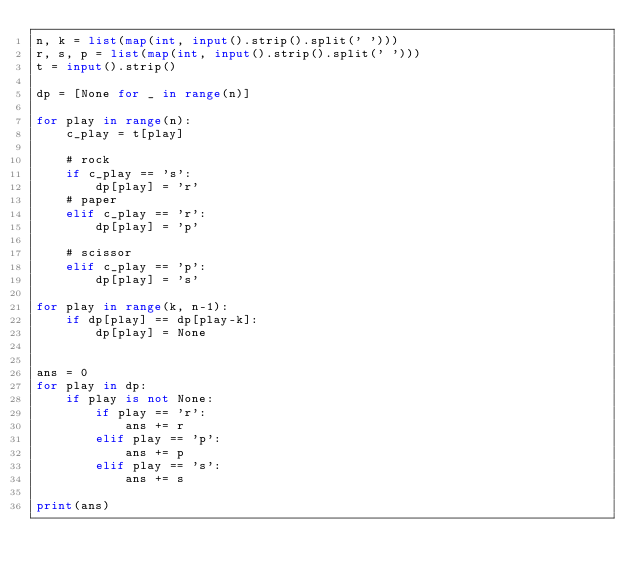<code> <loc_0><loc_0><loc_500><loc_500><_Python_>n, k = list(map(int, input().strip().split(' ')))
r, s, p = list(map(int, input().strip().split(' ')))
t = input().strip()

dp = [None for _ in range(n)]

for play in range(n):
    c_play = t[play] 

    # rock
    if c_play == 's':
        dp[play] = 'r'
    # paper
    elif c_play == 'r':
        dp[play] = 'p'

    # scissor
    elif c_play == 'p':
        dp[play] = 's'

for play in range(k, n-1):
    if dp[play] == dp[play-k]:
        dp[play] = None


ans = 0
for play in dp:
    if play is not None:
        if play == 'r':
            ans += r
        elif play == 'p':
            ans += p
        elif play == 's':
            ans += s

print(ans)
</code> 